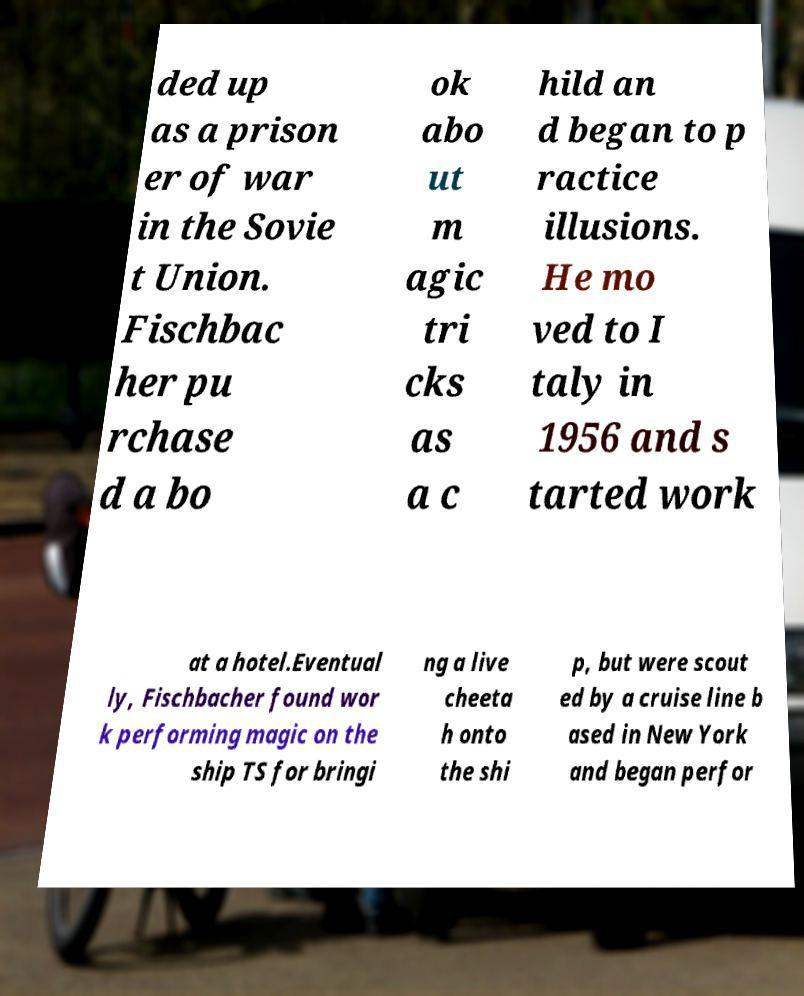For documentation purposes, I need the text within this image transcribed. Could you provide that? ded up as a prison er of war in the Sovie t Union. Fischbac her pu rchase d a bo ok abo ut m agic tri cks as a c hild an d began to p ractice illusions. He mo ved to I taly in 1956 and s tarted work at a hotel.Eventual ly, Fischbacher found wor k performing magic on the ship TS for bringi ng a live cheeta h onto the shi p, but were scout ed by a cruise line b ased in New York and began perfor 